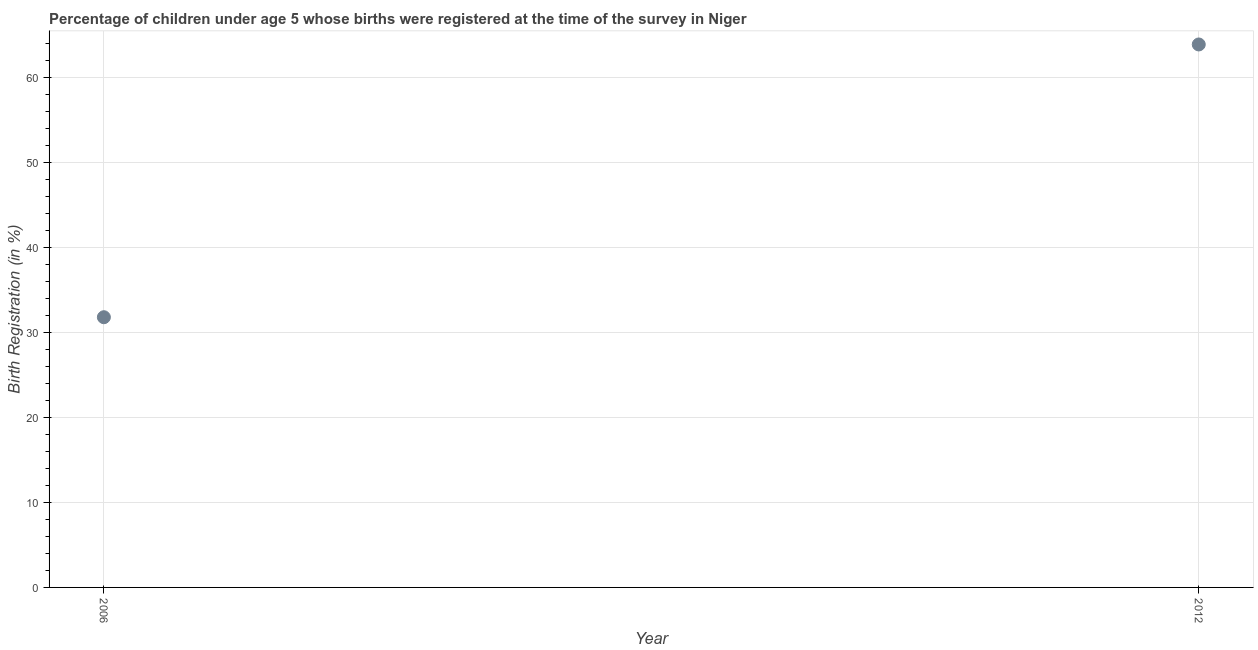What is the birth registration in 2012?
Offer a terse response. 63.9. Across all years, what is the maximum birth registration?
Your answer should be very brief. 63.9. Across all years, what is the minimum birth registration?
Give a very brief answer. 31.8. What is the sum of the birth registration?
Offer a very short reply. 95.7. What is the difference between the birth registration in 2006 and 2012?
Offer a terse response. -32.1. What is the average birth registration per year?
Your answer should be very brief. 47.85. What is the median birth registration?
Offer a terse response. 47.85. What is the ratio of the birth registration in 2006 to that in 2012?
Your answer should be very brief. 0.5. In how many years, is the birth registration greater than the average birth registration taken over all years?
Your answer should be compact. 1. Does the birth registration monotonically increase over the years?
Offer a very short reply. Yes. How many dotlines are there?
Provide a succinct answer. 1. How many years are there in the graph?
Provide a succinct answer. 2. Does the graph contain grids?
Offer a terse response. Yes. What is the title of the graph?
Make the answer very short. Percentage of children under age 5 whose births were registered at the time of the survey in Niger. What is the label or title of the X-axis?
Ensure brevity in your answer.  Year. What is the label or title of the Y-axis?
Give a very brief answer. Birth Registration (in %). What is the Birth Registration (in %) in 2006?
Make the answer very short. 31.8. What is the Birth Registration (in %) in 2012?
Make the answer very short. 63.9. What is the difference between the Birth Registration (in %) in 2006 and 2012?
Ensure brevity in your answer.  -32.1. What is the ratio of the Birth Registration (in %) in 2006 to that in 2012?
Offer a very short reply. 0.5. 